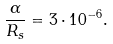<formula> <loc_0><loc_0><loc_500><loc_500>\frac { \alpha } { R _ { s } } = 3 \cdot 1 0 ^ { - 6 } .</formula> 